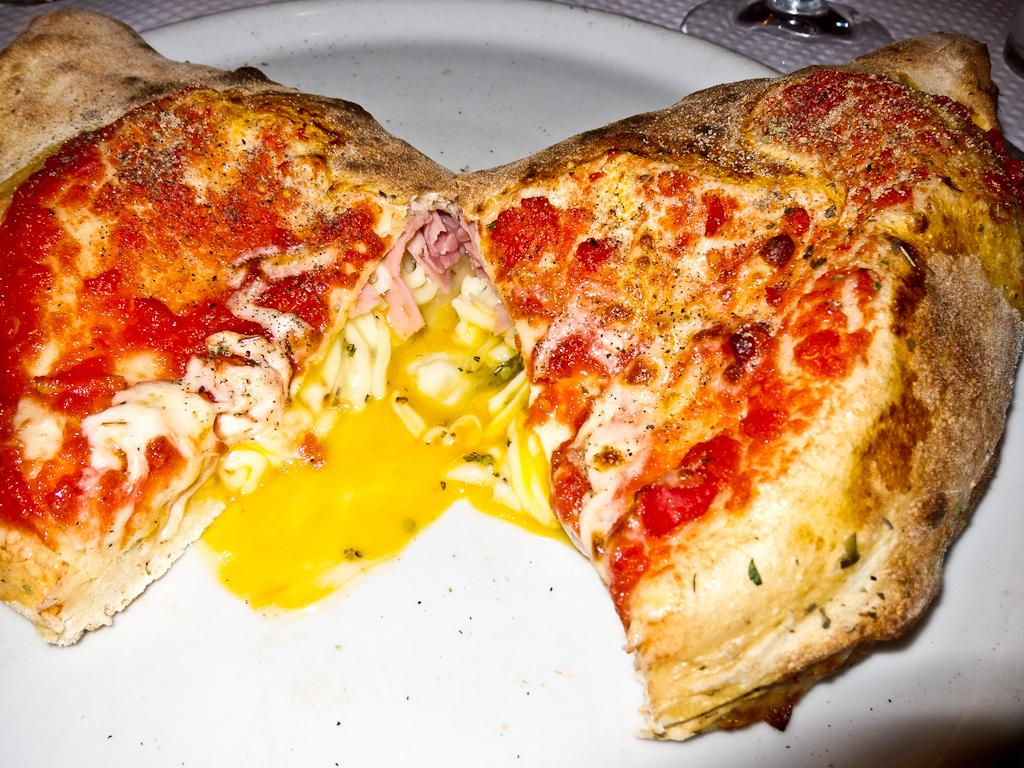What is located at the bottom of the image? There is a plate at the bottom of the image. What is on the plate? The plate contains food items. What else can be seen in the background of the image? There are glasses visible in the background of the image. Is there a cobweb hanging from the ceiling in the image? There is no mention of a cobweb in the provided facts, so we cannot determine if one is present in the image. 